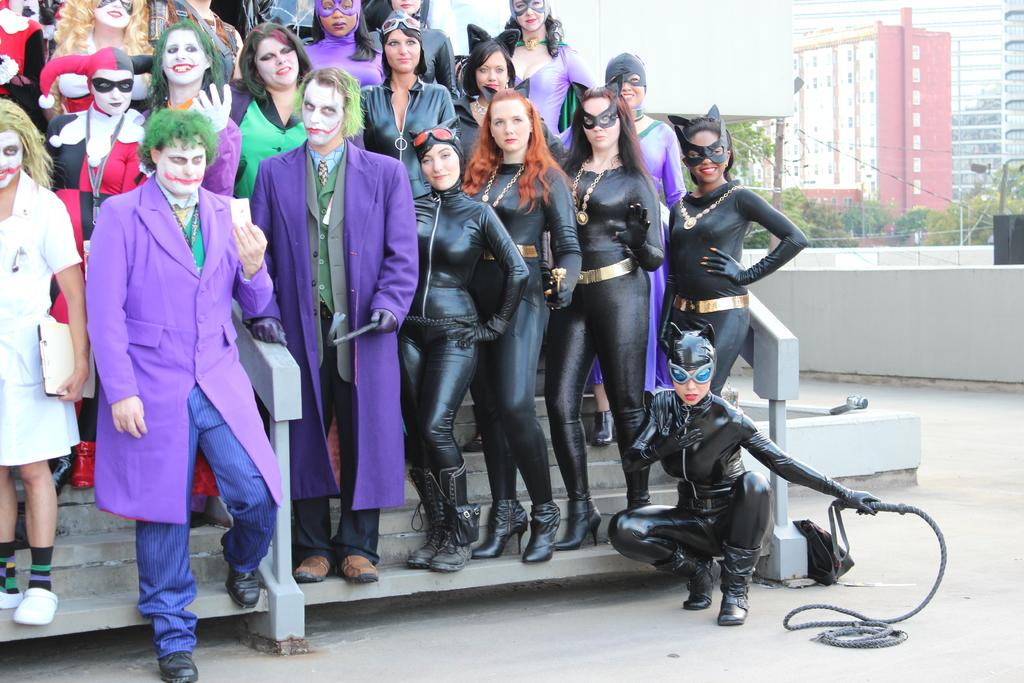How many people are in the image? There is a group of people in the image, but the exact number is not specified. What are the people wearing in the image? The people are wearing costumes in the image. What can be seen in the background of the image? There are trees and buildings in the background of the image. What objects are visible in the image? There are poles visible in the image. What type of machine is being used to smash the grain in the image? There is no machine or grain present in the image. How does the grain move around in the image? There is no grain present in the image, so it cannot move around. 